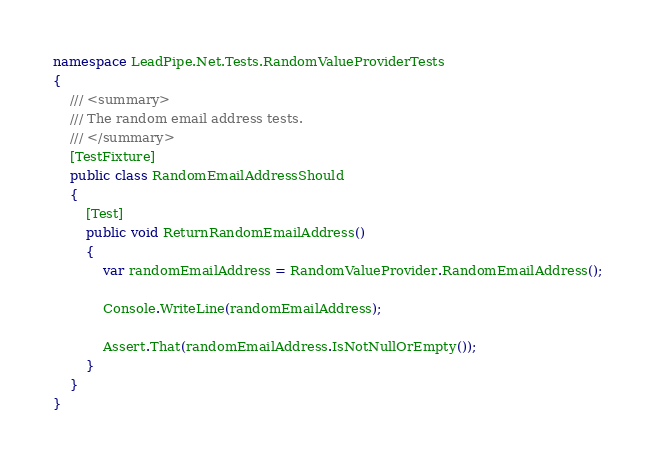<code> <loc_0><loc_0><loc_500><loc_500><_C#_>namespace LeadPipe.Net.Tests.RandomValueProviderTests
{
    /// <summary>
    /// The random email address tests.
    /// </summary>
    [TestFixture]
    public class RandomEmailAddressShould
    {
        [Test]
        public void ReturnRandomEmailAddress()
        {
            var randomEmailAddress = RandomValueProvider.RandomEmailAddress();

            Console.WriteLine(randomEmailAddress);

            Assert.That(randomEmailAddress.IsNotNullOrEmpty());
        }
    }
}</code> 